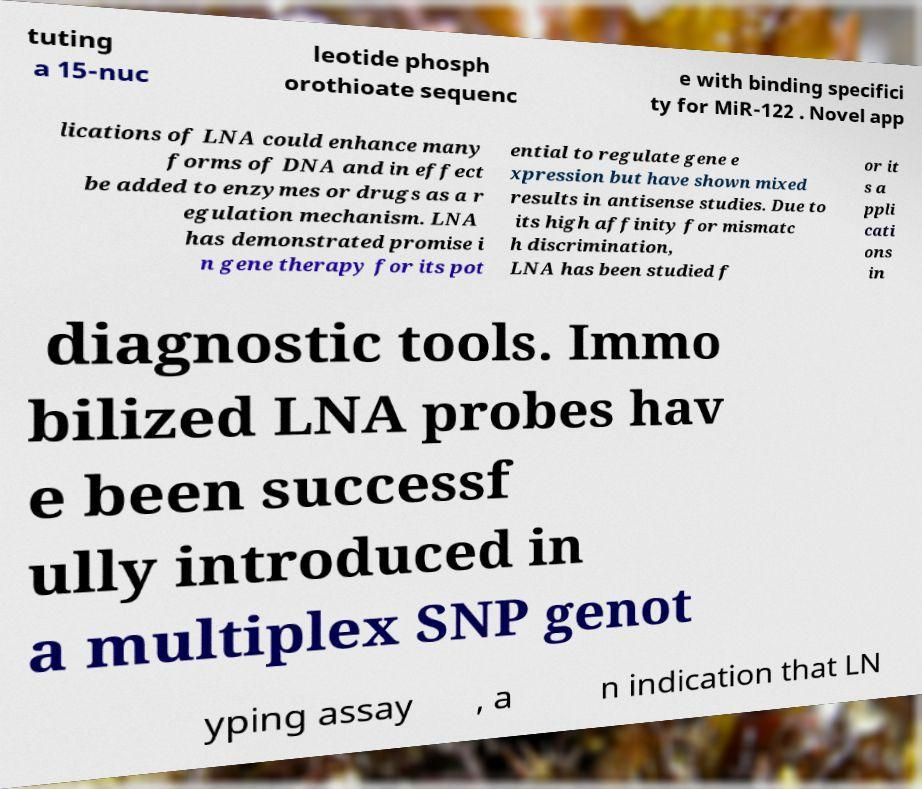Can you read and provide the text displayed in the image?This photo seems to have some interesting text. Can you extract and type it out for me? tuting a 15-nuc leotide phosph orothioate sequenc e with binding specifici ty for MiR-122 . Novel app lications of LNA could enhance many forms of DNA and in effect be added to enzymes or drugs as a r egulation mechanism. LNA has demonstrated promise i n gene therapy for its pot ential to regulate gene e xpression but have shown mixed results in antisense studies. Due to its high affinity for mismatc h discrimination, LNA has been studied f or it s a ppli cati ons in diagnostic tools. Immo bilized LNA probes hav e been successf ully introduced in a multiplex SNP genot yping assay , a n indication that LN 